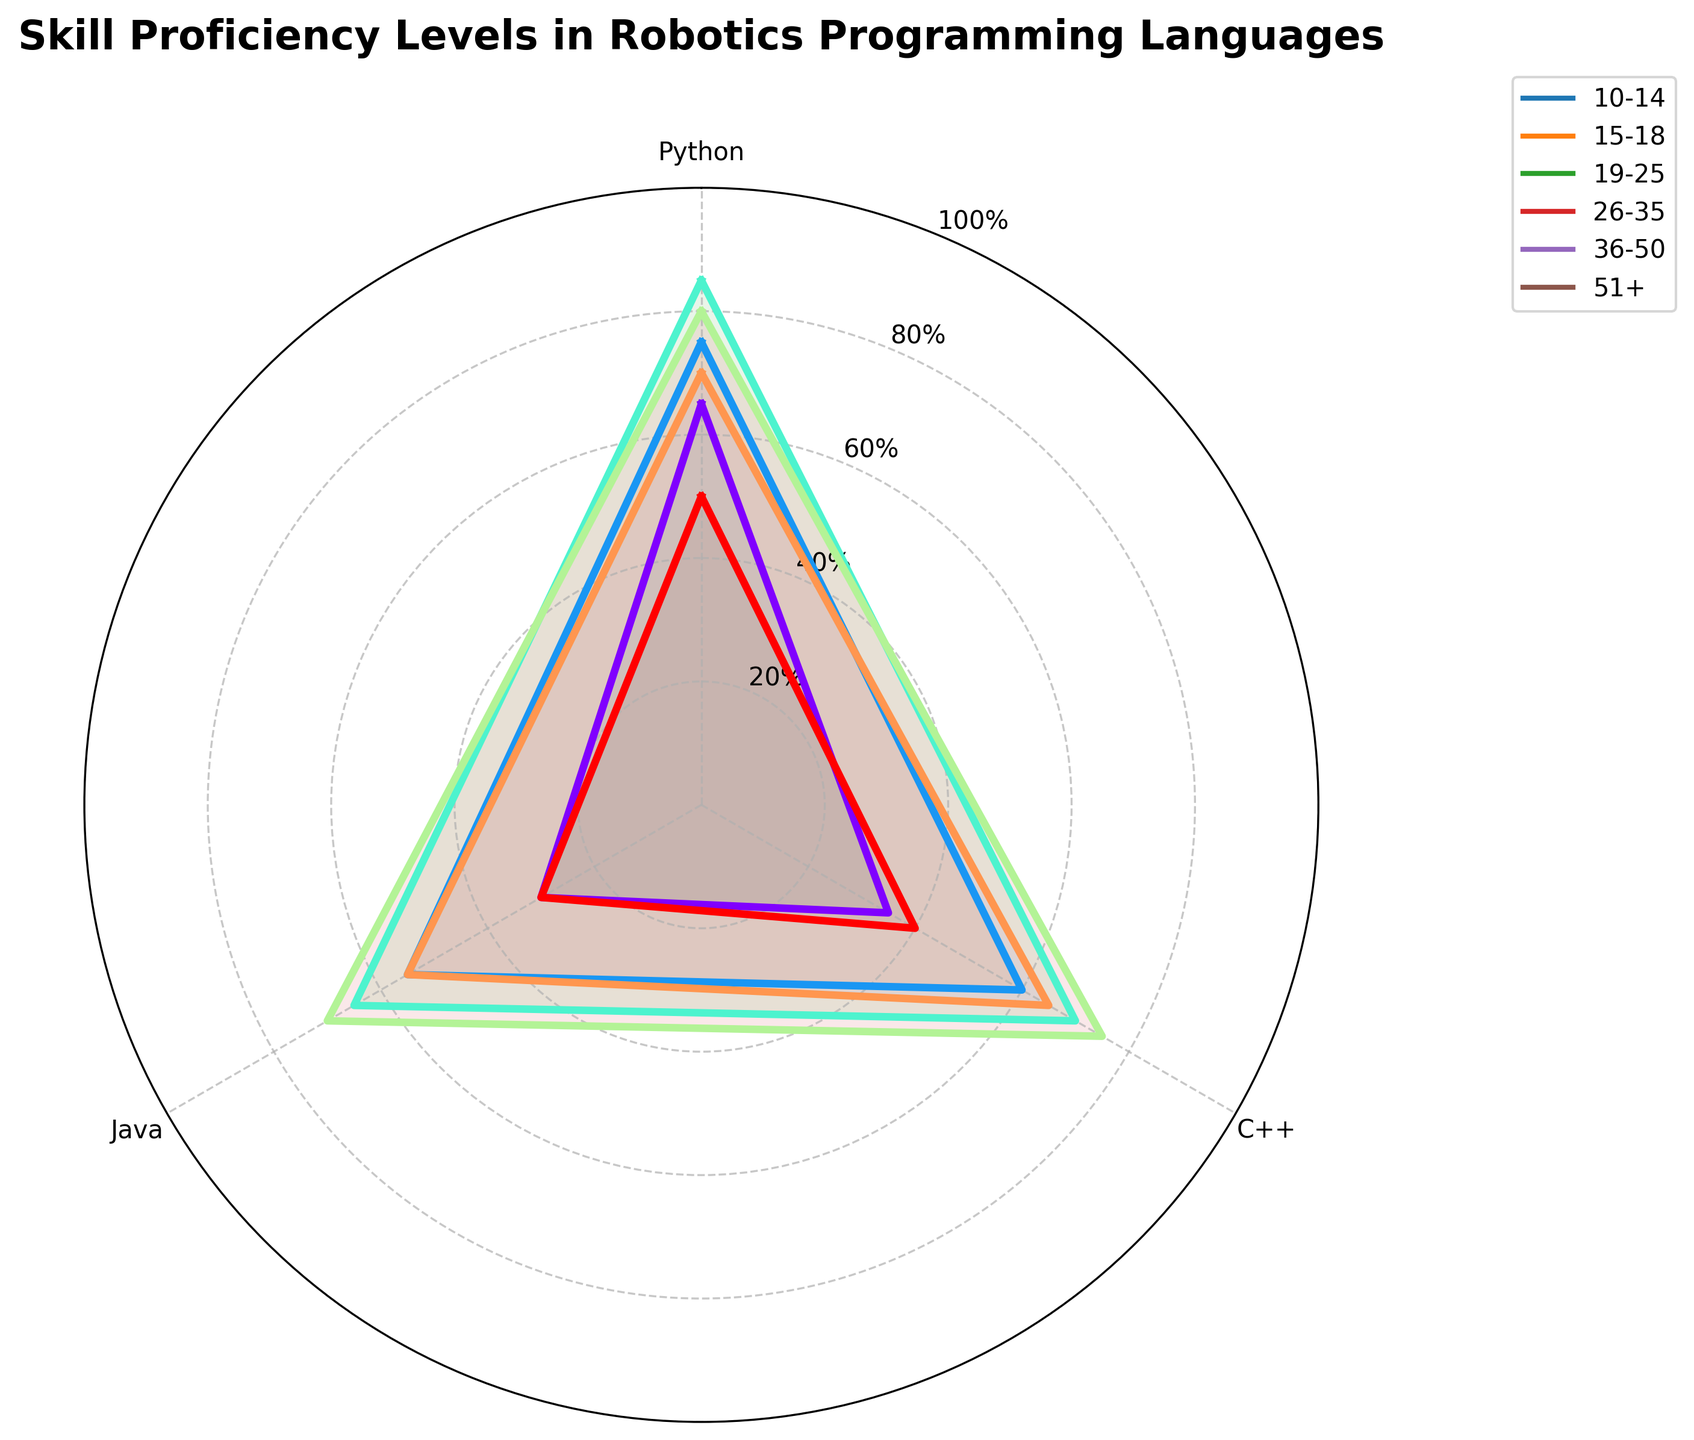What are the age groups represented in the radar chart? The radar chart includes lines labeled with different age groups. They are 10-14, 15-18, 19-25, 26-35, 36-50, and 51+
Answer: 10-14, 15-18, 19-25, 26-35, 36-50, 51+ Which programming language has the highest proficiency for the 19-25 age group? Observing the radar chart lines, the 19-25 age group shows different proficiency levels for each language. Python has the highest percentage for this group at around 85%.
Answer: Python What is the average proficiency level for Python across all age groups? The Python proficiency percentages across age groups are 65, 75, 85, 80, 70, and 50. Summing these percentages gives 425. Dividing by 6 (the number of age groups) results in an average proficiency level.
Answer: 70.83 How does the proficiency in C++ for the 36-50 age group compare to the 26-35 age group? The radar chart indicates these groups' proficiency levels in C++. For the 36-50 age group, it's 65%, while for the 26-35 age group, it's 75%.
Answer: 36-50 age group is 10% lower Which age group has the lowest proficiency in Java and what is the percentage? The lines on the radar chart show varying Java proficiency levels for each age group. The 51+ group has the lowest proficiency in Java at 30%.
Answer: 51+, 30% Compare the proficiency levels in Python for the 10-14 and 26-35 age groups. Who has a higher level and by how much? For Python, the chart shows the 10-14 age group at 65% proficiency and the 26-35 age group at 80%. The 26-35 group is higher by 15%.
Answer: 26-35, by 15% What is the range of proficiency levels in C++ among all age groups? The radar chart shows the proficiency levels in C++ for each age group: 35, 60, 70, 75, 65, and 40. The highest is 75% and the lowest is 35%. The range is the difference between these values.
Answer: 40% Which age group has the most balanced proficiency levels across Python, C++, and Java? By comparing the radar chart lines, we seek the group whose proficiency values for Python, C++, and Java are close to each other. The 15-18 age group shows relatively balanced levels of around 75, 60, and 55.
Answer: 15-18 age group 